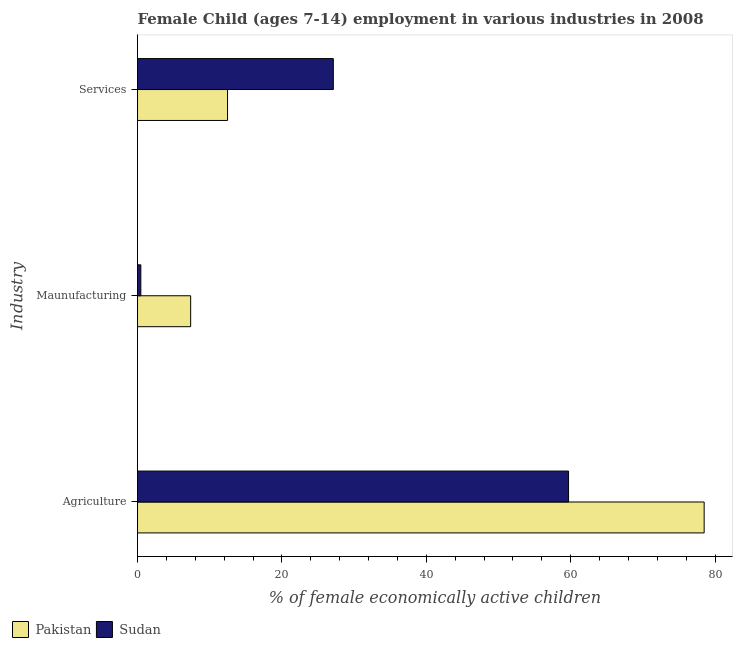How many different coloured bars are there?
Offer a terse response. 2. How many groups of bars are there?
Ensure brevity in your answer.  3. Are the number of bars per tick equal to the number of legend labels?
Your response must be concise. Yes. What is the label of the 2nd group of bars from the top?
Your response must be concise. Maunufacturing. What is the percentage of economically active children in manufacturing in Sudan?
Your answer should be compact. 0.46. Across all countries, what is the maximum percentage of economically active children in services?
Provide a succinct answer. 27.12. Across all countries, what is the minimum percentage of economically active children in agriculture?
Provide a short and direct response. 59.7. In which country was the percentage of economically active children in manufacturing maximum?
Keep it short and to the point. Pakistan. In which country was the percentage of economically active children in services minimum?
Your answer should be compact. Pakistan. What is the total percentage of economically active children in agriculture in the graph?
Your answer should be compact. 138.18. What is the difference between the percentage of economically active children in services in Sudan and that in Pakistan?
Provide a succinct answer. 14.65. What is the difference between the percentage of economically active children in manufacturing in Sudan and the percentage of economically active children in services in Pakistan?
Provide a succinct answer. -12.01. What is the average percentage of economically active children in manufacturing per country?
Provide a short and direct response. 3.91. What is the difference between the percentage of economically active children in manufacturing and percentage of economically active children in agriculture in Pakistan?
Offer a terse response. -71.12. What is the ratio of the percentage of economically active children in agriculture in Sudan to that in Pakistan?
Your answer should be compact. 0.76. Is the difference between the percentage of economically active children in agriculture in Pakistan and Sudan greater than the difference between the percentage of economically active children in services in Pakistan and Sudan?
Give a very brief answer. Yes. What is the difference between the highest and the lowest percentage of economically active children in services?
Provide a succinct answer. 14.65. In how many countries, is the percentage of economically active children in agriculture greater than the average percentage of economically active children in agriculture taken over all countries?
Your answer should be compact. 1. What does the 2nd bar from the top in Maunufacturing represents?
Offer a very short reply. Pakistan. Is it the case that in every country, the sum of the percentage of economically active children in agriculture and percentage of economically active children in manufacturing is greater than the percentage of economically active children in services?
Your answer should be compact. Yes. How many countries are there in the graph?
Ensure brevity in your answer.  2. What is the difference between two consecutive major ticks on the X-axis?
Your answer should be very brief. 20. Does the graph contain any zero values?
Ensure brevity in your answer.  No. What is the title of the graph?
Provide a succinct answer. Female Child (ages 7-14) employment in various industries in 2008. Does "Bosnia and Herzegovina" appear as one of the legend labels in the graph?
Your answer should be compact. No. What is the label or title of the X-axis?
Make the answer very short. % of female economically active children. What is the label or title of the Y-axis?
Give a very brief answer. Industry. What is the % of female economically active children in Pakistan in Agriculture?
Provide a succinct answer. 78.48. What is the % of female economically active children in Sudan in Agriculture?
Your response must be concise. 59.7. What is the % of female economically active children in Pakistan in Maunufacturing?
Ensure brevity in your answer.  7.36. What is the % of female economically active children in Sudan in Maunufacturing?
Provide a succinct answer. 0.46. What is the % of female economically active children in Pakistan in Services?
Ensure brevity in your answer.  12.47. What is the % of female economically active children in Sudan in Services?
Offer a terse response. 27.12. Across all Industry, what is the maximum % of female economically active children in Pakistan?
Give a very brief answer. 78.48. Across all Industry, what is the maximum % of female economically active children of Sudan?
Make the answer very short. 59.7. Across all Industry, what is the minimum % of female economically active children in Pakistan?
Make the answer very short. 7.36. Across all Industry, what is the minimum % of female economically active children of Sudan?
Give a very brief answer. 0.46. What is the total % of female economically active children in Pakistan in the graph?
Your answer should be compact. 98.31. What is the total % of female economically active children of Sudan in the graph?
Provide a succinct answer. 87.28. What is the difference between the % of female economically active children in Pakistan in Agriculture and that in Maunufacturing?
Ensure brevity in your answer.  71.12. What is the difference between the % of female economically active children of Sudan in Agriculture and that in Maunufacturing?
Your answer should be compact. 59.24. What is the difference between the % of female economically active children in Pakistan in Agriculture and that in Services?
Your response must be concise. 66.01. What is the difference between the % of female economically active children of Sudan in Agriculture and that in Services?
Provide a short and direct response. 32.58. What is the difference between the % of female economically active children of Pakistan in Maunufacturing and that in Services?
Make the answer very short. -5.11. What is the difference between the % of female economically active children in Sudan in Maunufacturing and that in Services?
Your response must be concise. -26.66. What is the difference between the % of female economically active children in Pakistan in Agriculture and the % of female economically active children in Sudan in Maunufacturing?
Provide a succinct answer. 78.02. What is the difference between the % of female economically active children in Pakistan in Agriculture and the % of female economically active children in Sudan in Services?
Offer a terse response. 51.36. What is the difference between the % of female economically active children in Pakistan in Maunufacturing and the % of female economically active children in Sudan in Services?
Your answer should be very brief. -19.76. What is the average % of female economically active children of Pakistan per Industry?
Offer a very short reply. 32.77. What is the average % of female economically active children in Sudan per Industry?
Your answer should be compact. 29.09. What is the difference between the % of female economically active children of Pakistan and % of female economically active children of Sudan in Agriculture?
Offer a terse response. 18.78. What is the difference between the % of female economically active children in Pakistan and % of female economically active children in Sudan in Maunufacturing?
Make the answer very short. 6.9. What is the difference between the % of female economically active children in Pakistan and % of female economically active children in Sudan in Services?
Make the answer very short. -14.65. What is the ratio of the % of female economically active children of Pakistan in Agriculture to that in Maunufacturing?
Ensure brevity in your answer.  10.66. What is the ratio of the % of female economically active children in Sudan in Agriculture to that in Maunufacturing?
Provide a short and direct response. 129.78. What is the ratio of the % of female economically active children in Pakistan in Agriculture to that in Services?
Your answer should be very brief. 6.29. What is the ratio of the % of female economically active children of Sudan in Agriculture to that in Services?
Provide a succinct answer. 2.2. What is the ratio of the % of female economically active children in Pakistan in Maunufacturing to that in Services?
Provide a succinct answer. 0.59. What is the ratio of the % of female economically active children of Sudan in Maunufacturing to that in Services?
Provide a succinct answer. 0.02. What is the difference between the highest and the second highest % of female economically active children of Pakistan?
Keep it short and to the point. 66.01. What is the difference between the highest and the second highest % of female economically active children in Sudan?
Your answer should be very brief. 32.58. What is the difference between the highest and the lowest % of female economically active children of Pakistan?
Your answer should be compact. 71.12. What is the difference between the highest and the lowest % of female economically active children of Sudan?
Give a very brief answer. 59.24. 